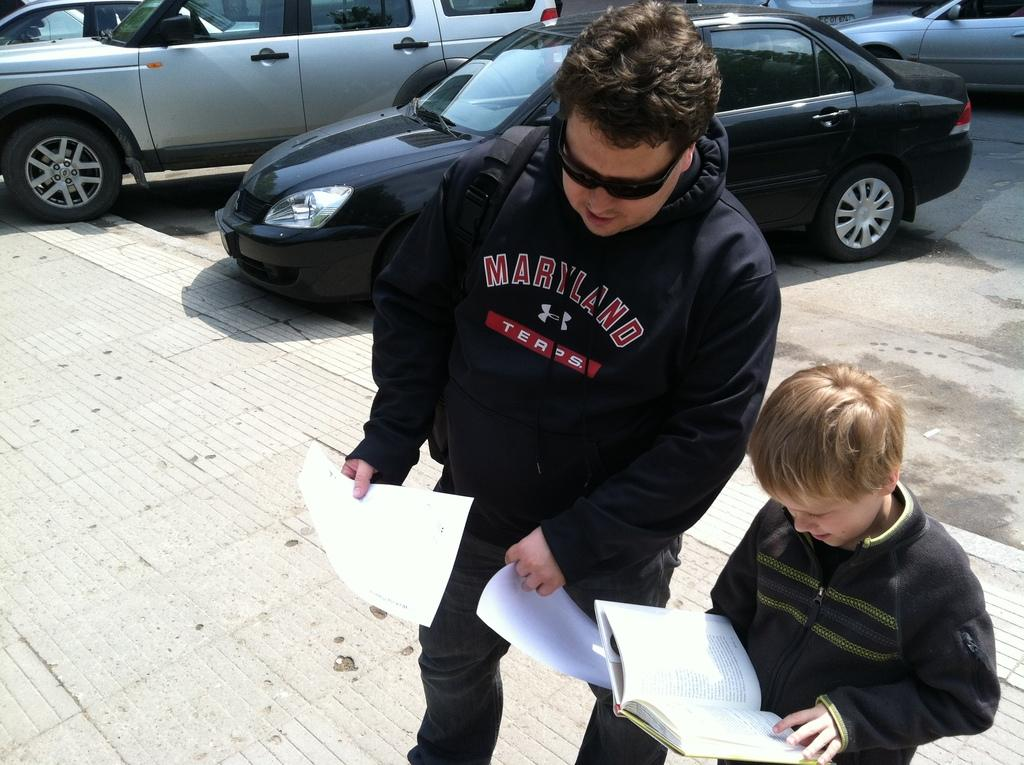How many people are in the image? There are two persons in the image. What are the persons doing in the image? The persons are standing and holding a book and papers. What can be seen in the background of the image? Cars are visible in the background of the image, and they are on a road. What type of fish can be seen swimming in the book held by the persons in the image? There are no fish present in the image; the persons are holding a book and papers. What genre of fiction is the book about that the persons are holding in the image? The genre of fiction cannot be determined from the image, as the book's title or content is not visible. 